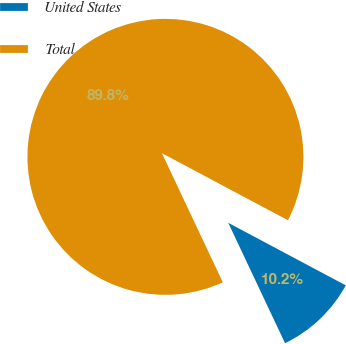Convert chart to OTSL. <chart><loc_0><loc_0><loc_500><loc_500><pie_chart><fcel>United States<fcel>Total<nl><fcel>10.2%<fcel>89.8%<nl></chart> 